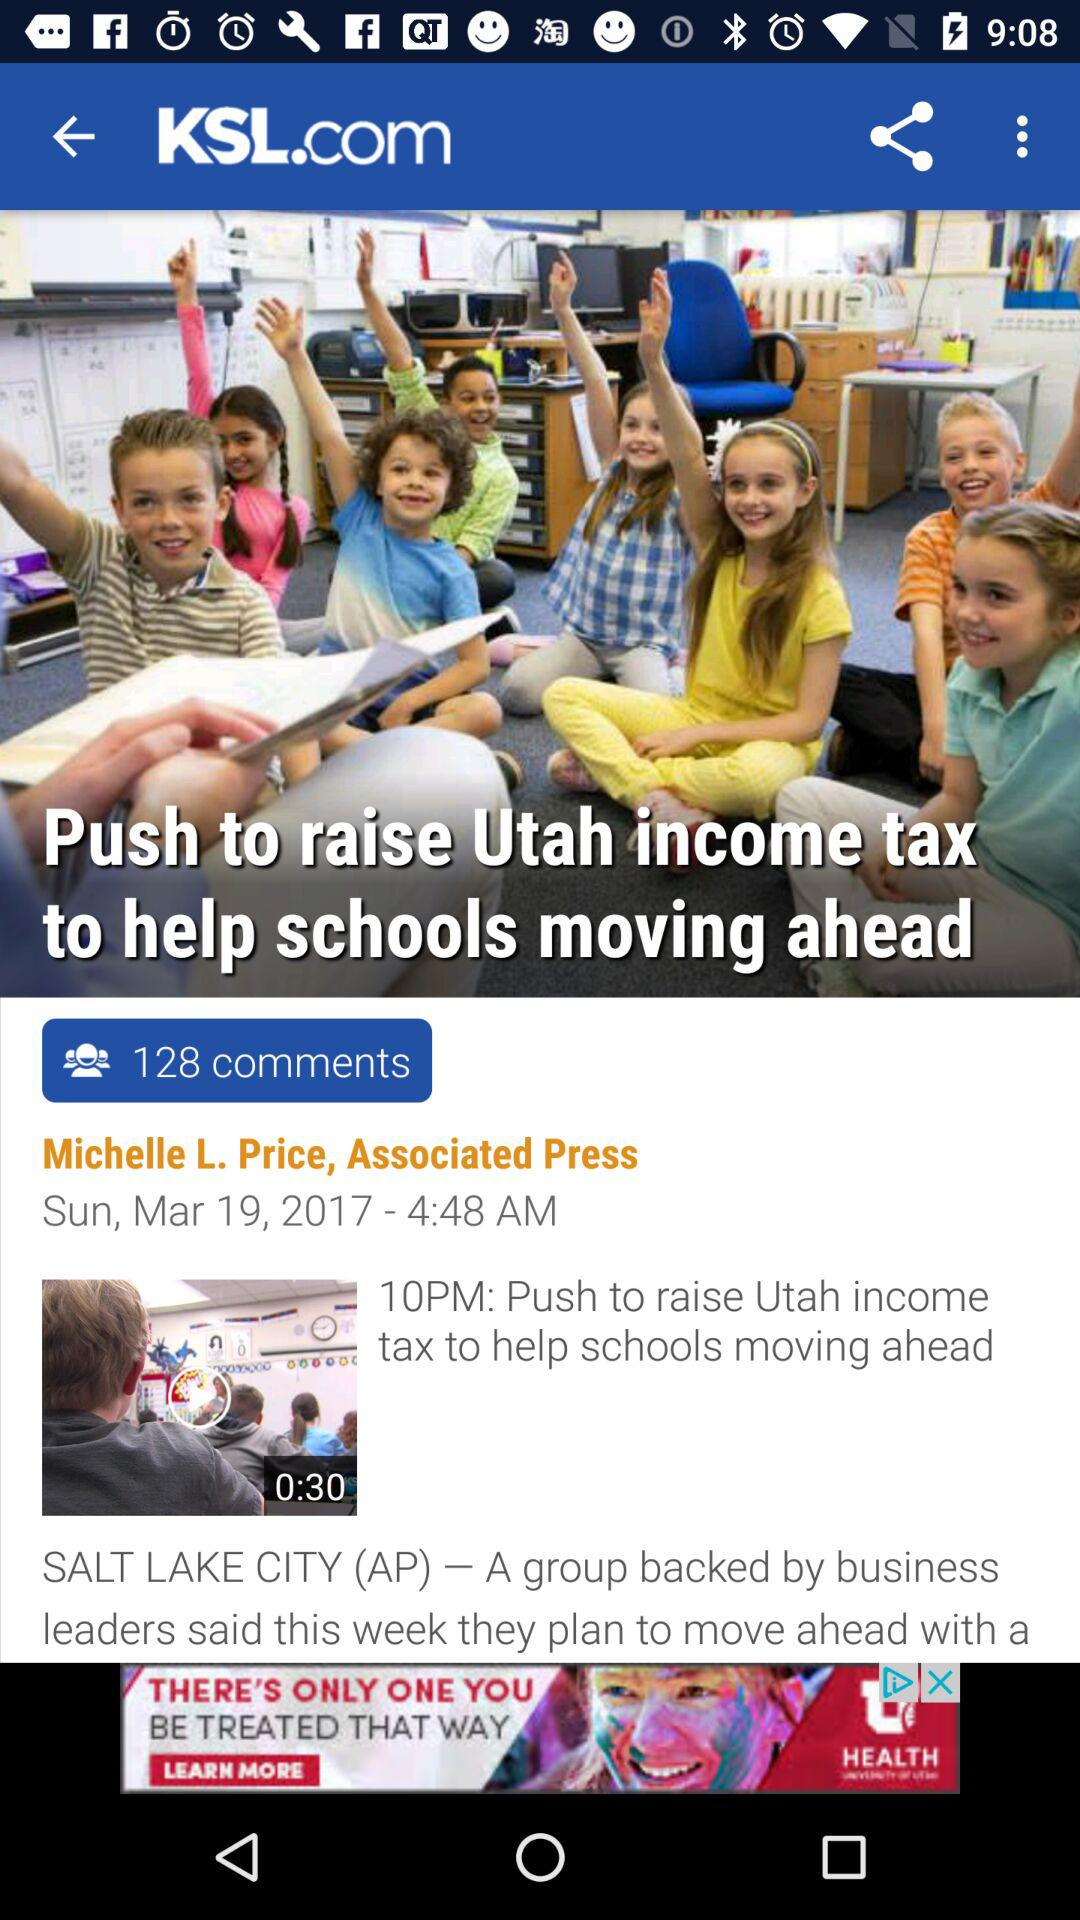What is the author name? The author name is "Michelle L. Price". 